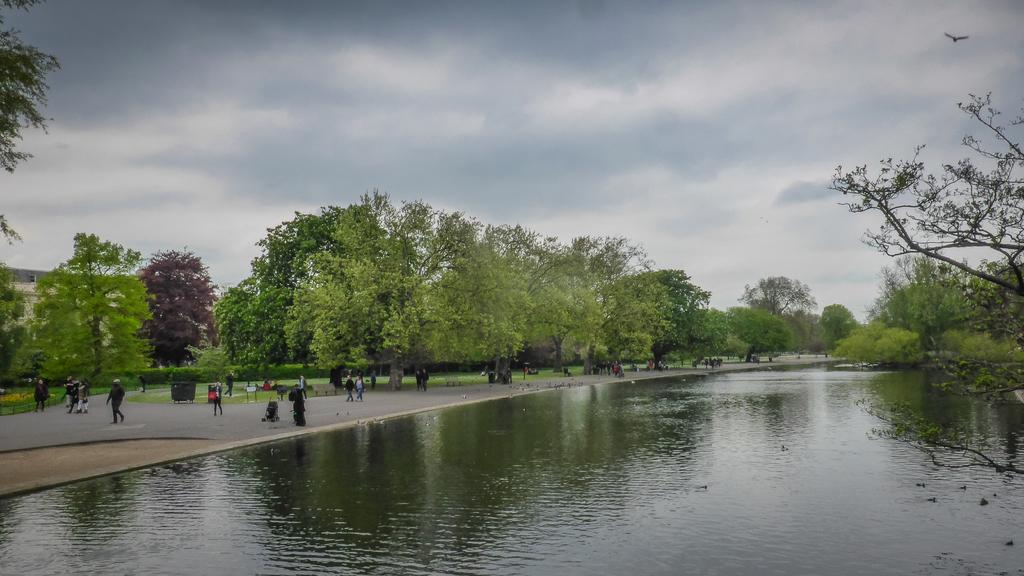What body of water is visible in the image? There is a lake in the front of the image. What can be found on the left side of the image? There is land and trees on the left side of the image. What are the people in the image doing? People are walking on a road in the image. What is visible in the sky in the image? The sky is visible in the image, and clouds are present. What is the name of the playground located near the lake in the image? There is no playground present in the image. Can you tell me the cost of the items on the receipt in the image? There is no receipt present in the image. 